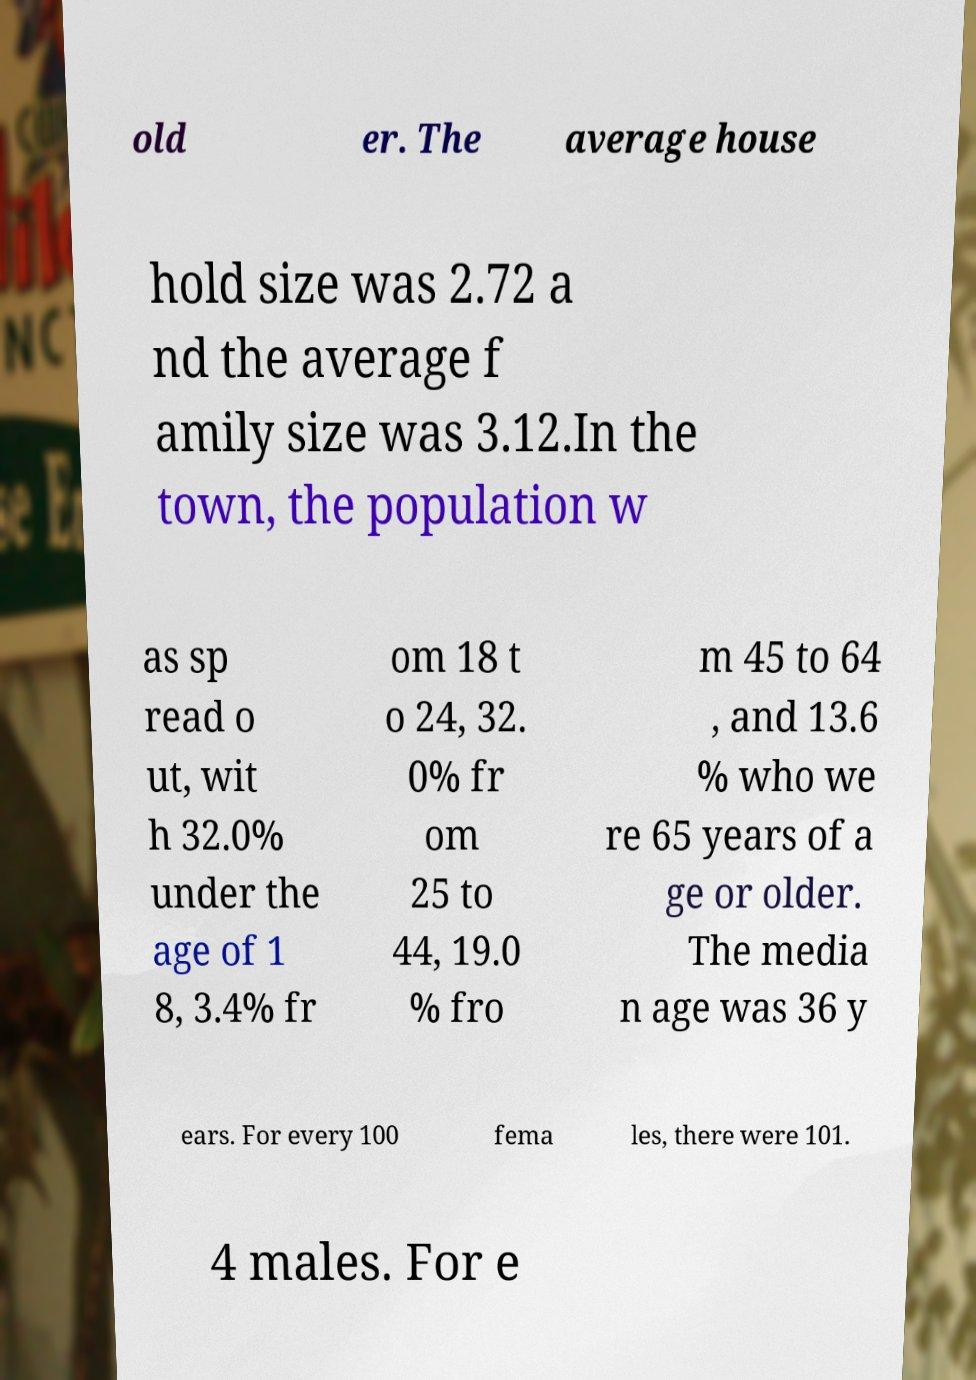Can you accurately transcribe the text from the provided image for me? old er. The average house hold size was 2.72 a nd the average f amily size was 3.12.In the town, the population w as sp read o ut, wit h 32.0% under the age of 1 8, 3.4% fr om 18 t o 24, 32. 0% fr om 25 to 44, 19.0 % fro m 45 to 64 , and 13.6 % who we re 65 years of a ge or older. The media n age was 36 y ears. For every 100 fema les, there were 101. 4 males. For e 